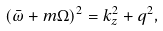Convert formula to latex. <formula><loc_0><loc_0><loc_500><loc_500>( \bar { \omega } + m \Omega ) ^ { 2 } = k _ { z } ^ { 2 } + q ^ { 2 } ,</formula> 